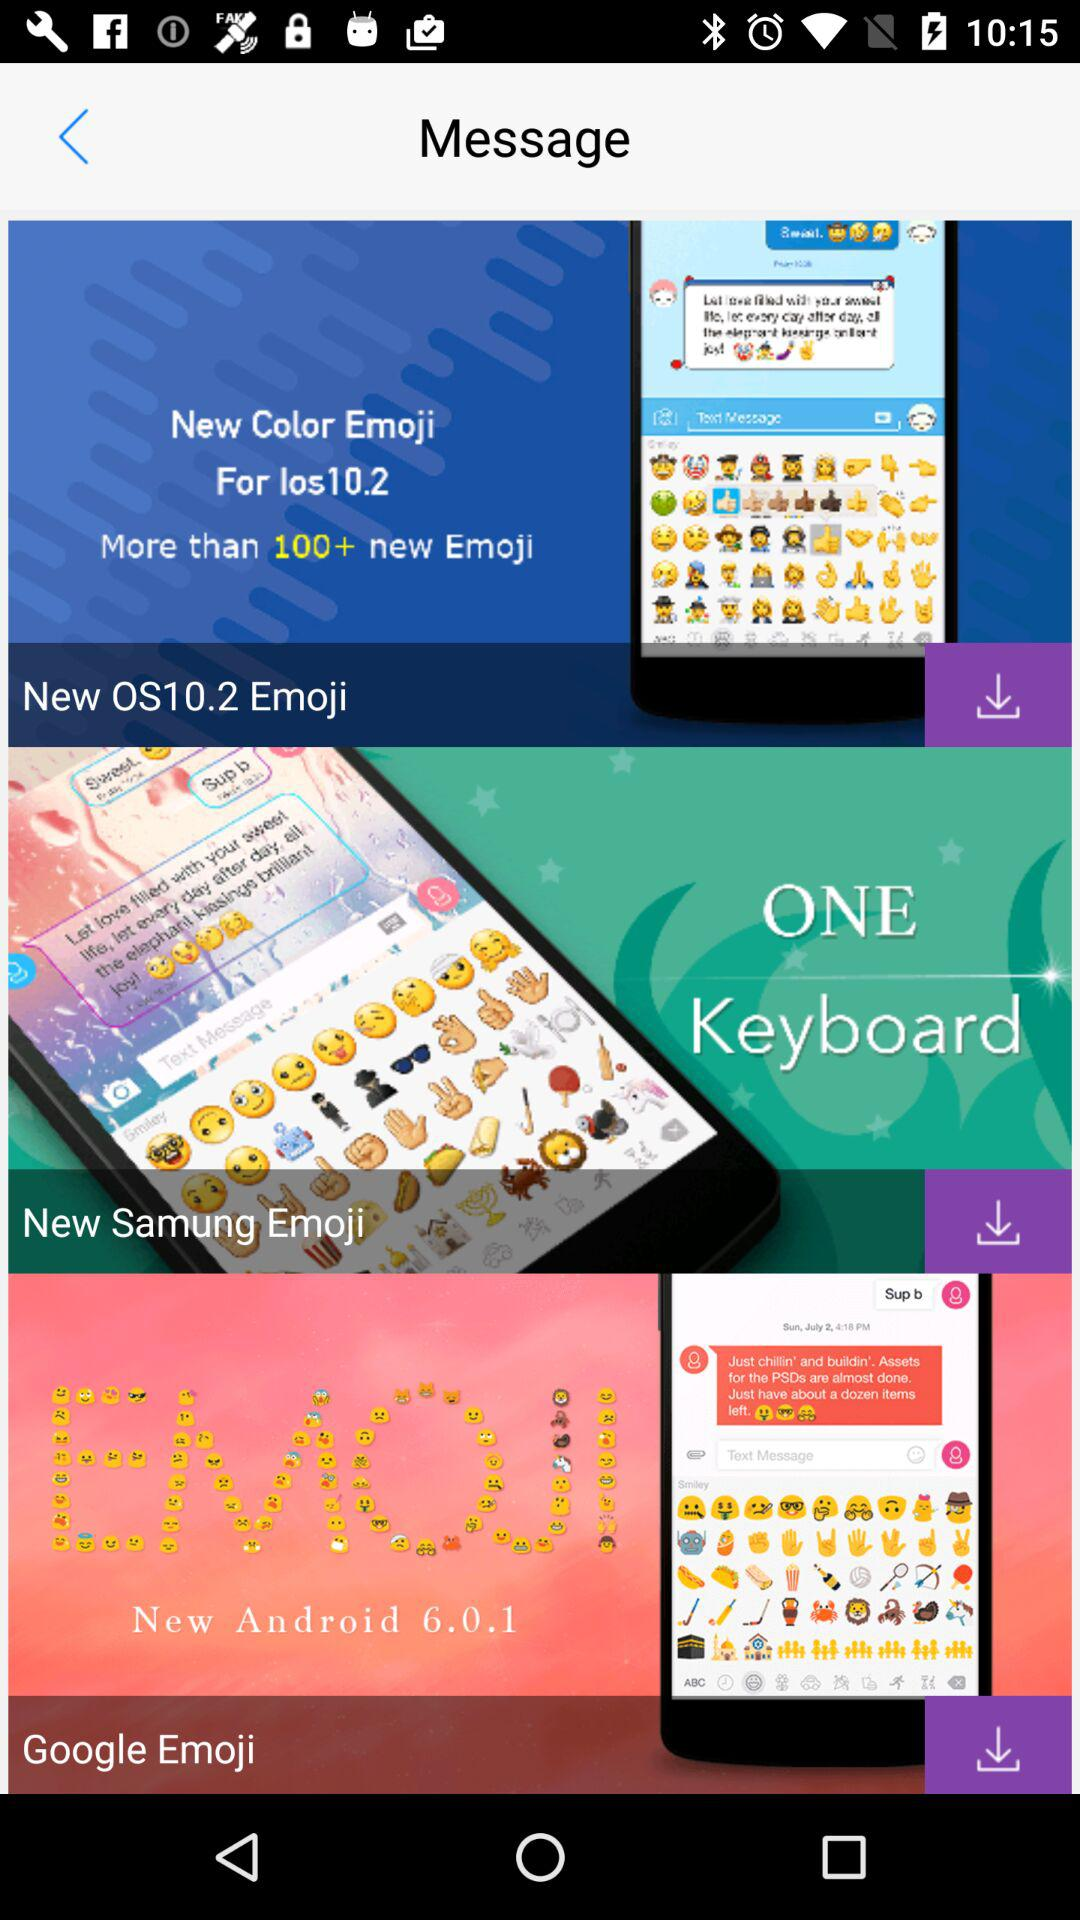What is the new Android version? The new Android version is 6.0.1. 